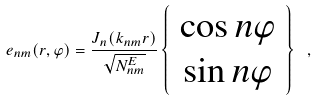Convert formula to latex. <formula><loc_0><loc_0><loc_500><loc_500>e _ { n m } ( r , \varphi ) = \frac { J _ { n } ( k _ { n m } r ) } { \sqrt { N ^ { E } _ { n m } } } \left \{ \begin{array} { c } \cos { n \varphi } \\ \sin { n \varphi } \end{array} \right \} \ ,</formula> 